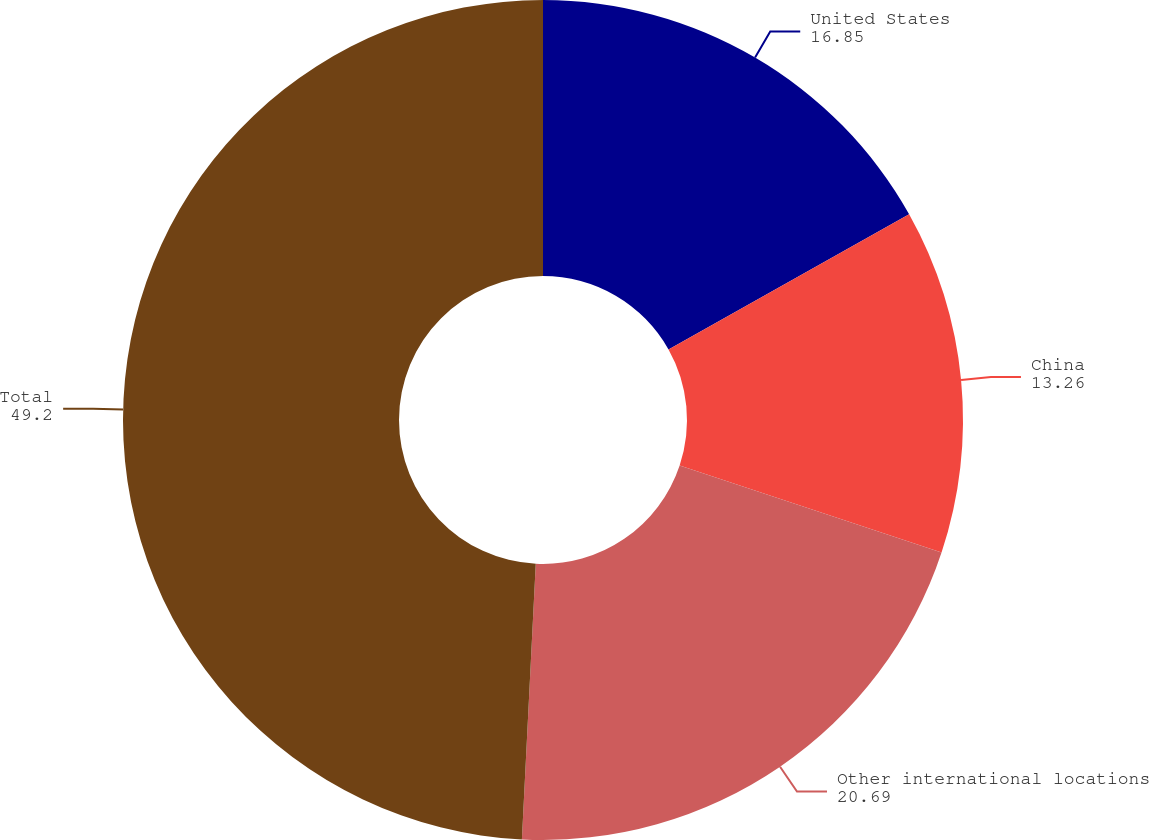Convert chart. <chart><loc_0><loc_0><loc_500><loc_500><pie_chart><fcel>United States<fcel>China<fcel>Other international locations<fcel>Total<nl><fcel>16.85%<fcel>13.26%<fcel>20.69%<fcel>49.2%<nl></chart> 